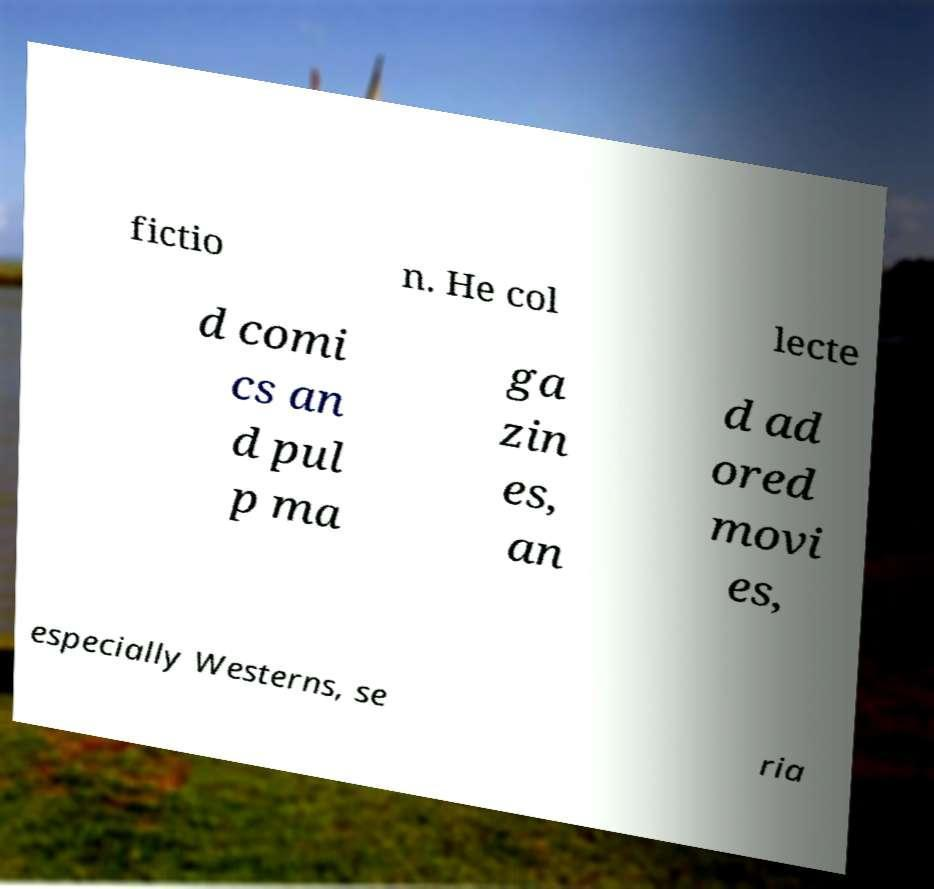Please read and relay the text visible in this image. What does it say? fictio n. He col lecte d comi cs an d pul p ma ga zin es, an d ad ored movi es, especially Westerns, se ria 